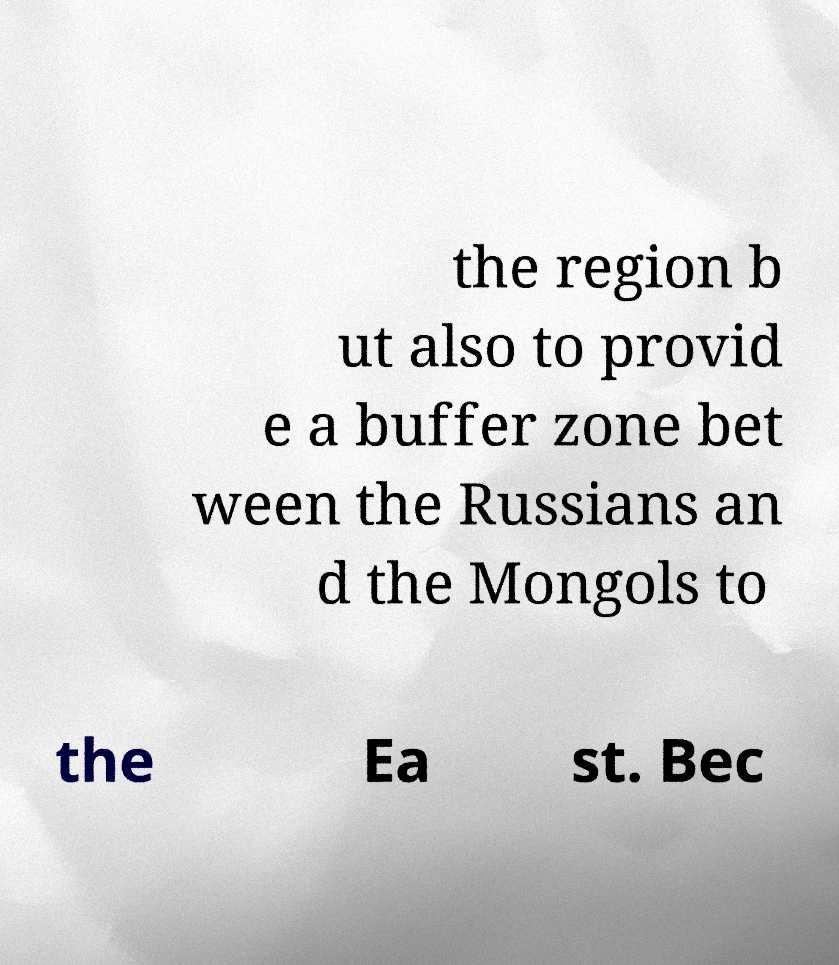For documentation purposes, I need the text within this image transcribed. Could you provide that? the region b ut also to provid e a buffer zone bet ween the Russians an d the Mongols to the Ea st. Bec 